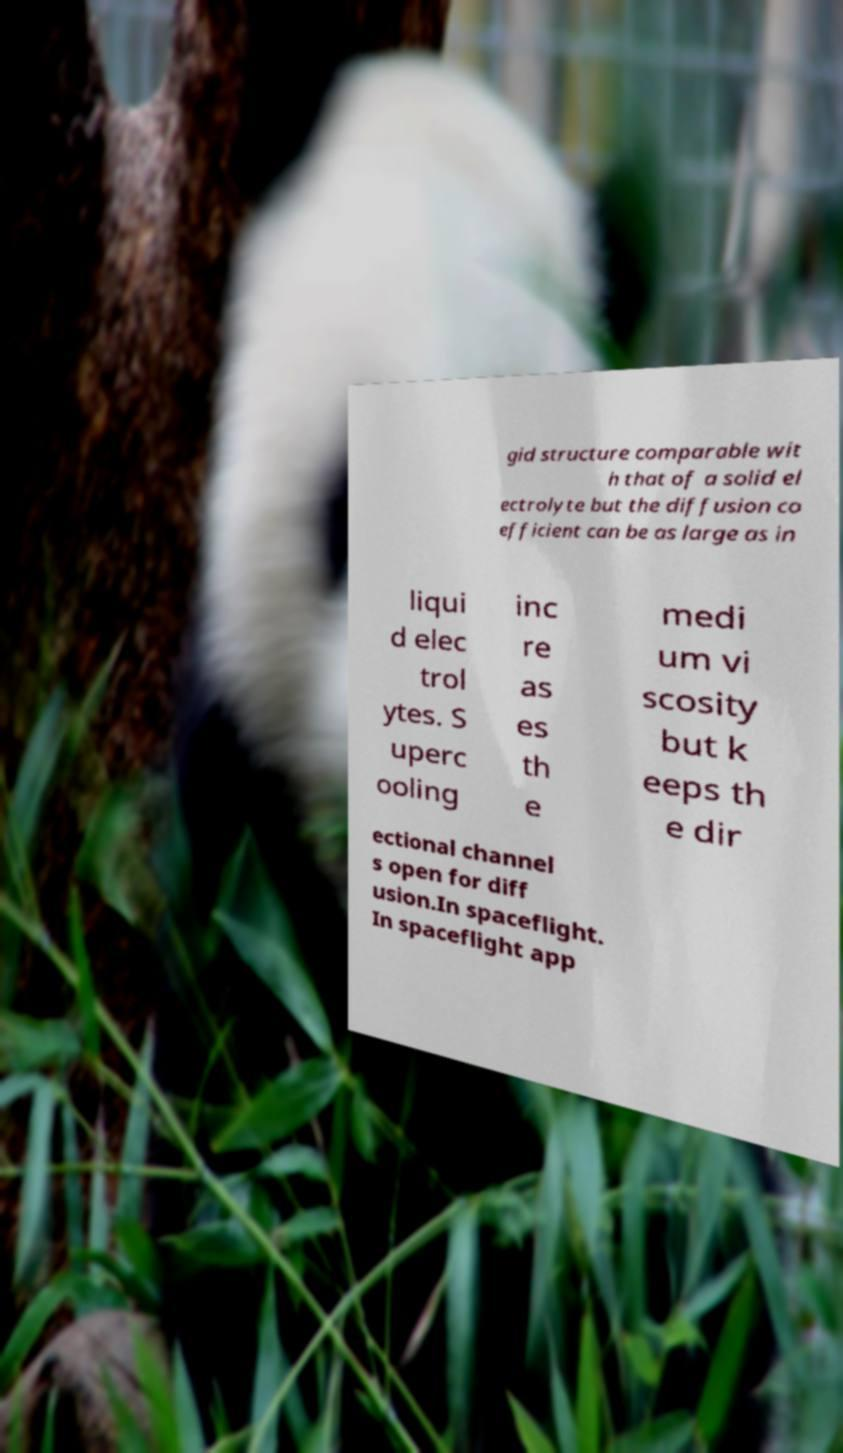Could you assist in decoding the text presented in this image and type it out clearly? gid structure comparable wit h that of a solid el ectrolyte but the diffusion co efficient can be as large as in liqui d elec trol ytes. S uperc ooling inc re as es th e medi um vi scosity but k eeps th e dir ectional channel s open for diff usion.In spaceflight. In spaceflight app 